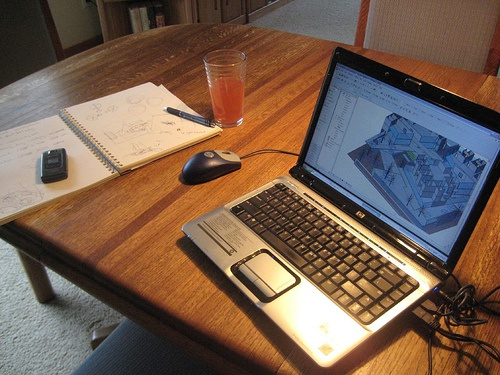Describe the objects in this image and their specific colors. I can see dining table in black, brown, and maroon tones, laptop in black, gray, and ivory tones, book in black, tan, darkgray, and gray tones, chair in black, gray, brown, and maroon tones, and chair in black, blue, and gray tones in this image. 